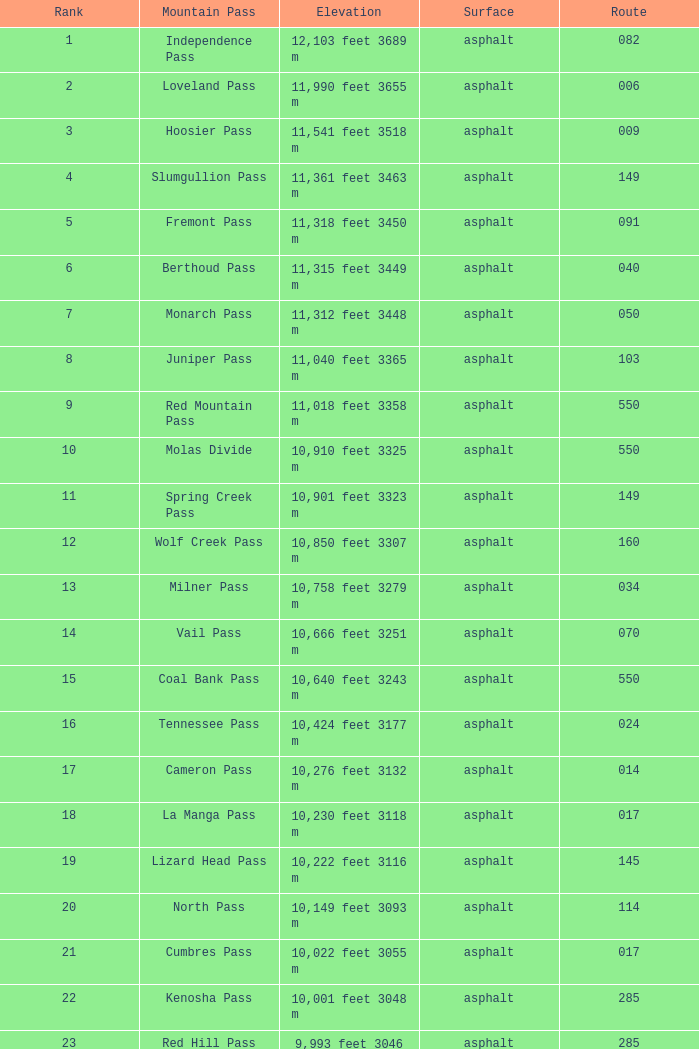Which mountain pass has a height of 10,001 feet 3048 m? Kenosha Pass. 